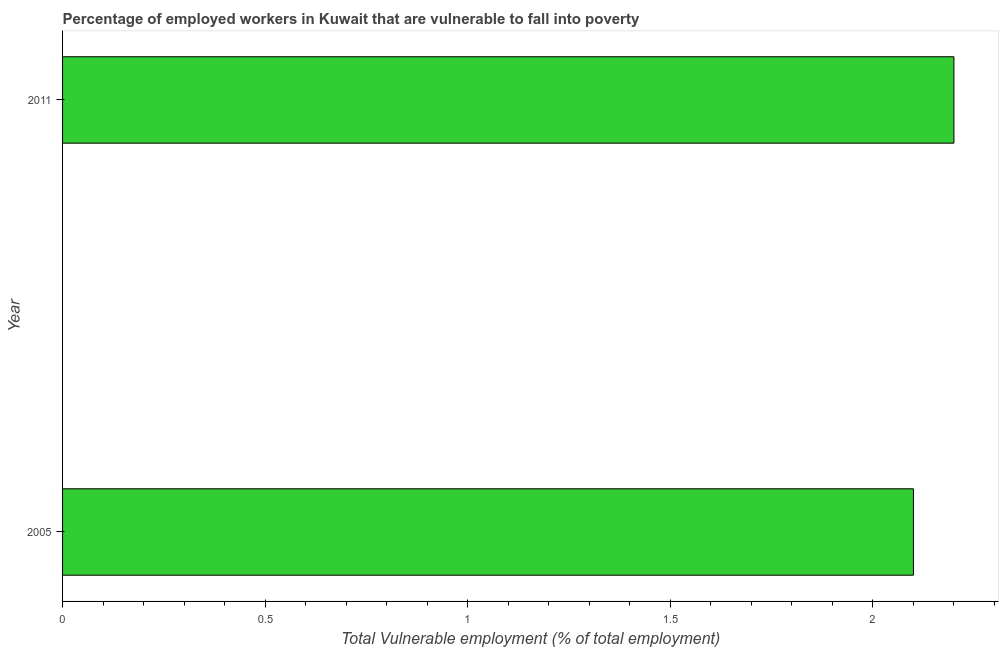Does the graph contain grids?
Offer a terse response. No. What is the title of the graph?
Your answer should be very brief. Percentage of employed workers in Kuwait that are vulnerable to fall into poverty. What is the label or title of the X-axis?
Your response must be concise. Total Vulnerable employment (% of total employment). What is the total vulnerable employment in 2011?
Ensure brevity in your answer.  2.2. Across all years, what is the maximum total vulnerable employment?
Provide a short and direct response. 2.2. Across all years, what is the minimum total vulnerable employment?
Keep it short and to the point. 2.1. In which year was the total vulnerable employment minimum?
Keep it short and to the point. 2005. What is the sum of the total vulnerable employment?
Keep it short and to the point. 4.3. What is the average total vulnerable employment per year?
Provide a short and direct response. 2.15. What is the median total vulnerable employment?
Provide a succinct answer. 2.15. In how many years, is the total vulnerable employment greater than 0.1 %?
Make the answer very short. 2. Do a majority of the years between 2011 and 2005 (inclusive) have total vulnerable employment greater than 1.8 %?
Provide a succinct answer. No. What is the ratio of the total vulnerable employment in 2005 to that in 2011?
Your response must be concise. 0.95. Is the total vulnerable employment in 2005 less than that in 2011?
Your response must be concise. Yes. How many years are there in the graph?
Your response must be concise. 2. Are the values on the major ticks of X-axis written in scientific E-notation?
Give a very brief answer. No. What is the Total Vulnerable employment (% of total employment) of 2005?
Provide a short and direct response. 2.1. What is the Total Vulnerable employment (% of total employment) of 2011?
Keep it short and to the point. 2.2. What is the difference between the Total Vulnerable employment (% of total employment) in 2005 and 2011?
Your answer should be compact. -0.1. What is the ratio of the Total Vulnerable employment (% of total employment) in 2005 to that in 2011?
Keep it short and to the point. 0.95. 